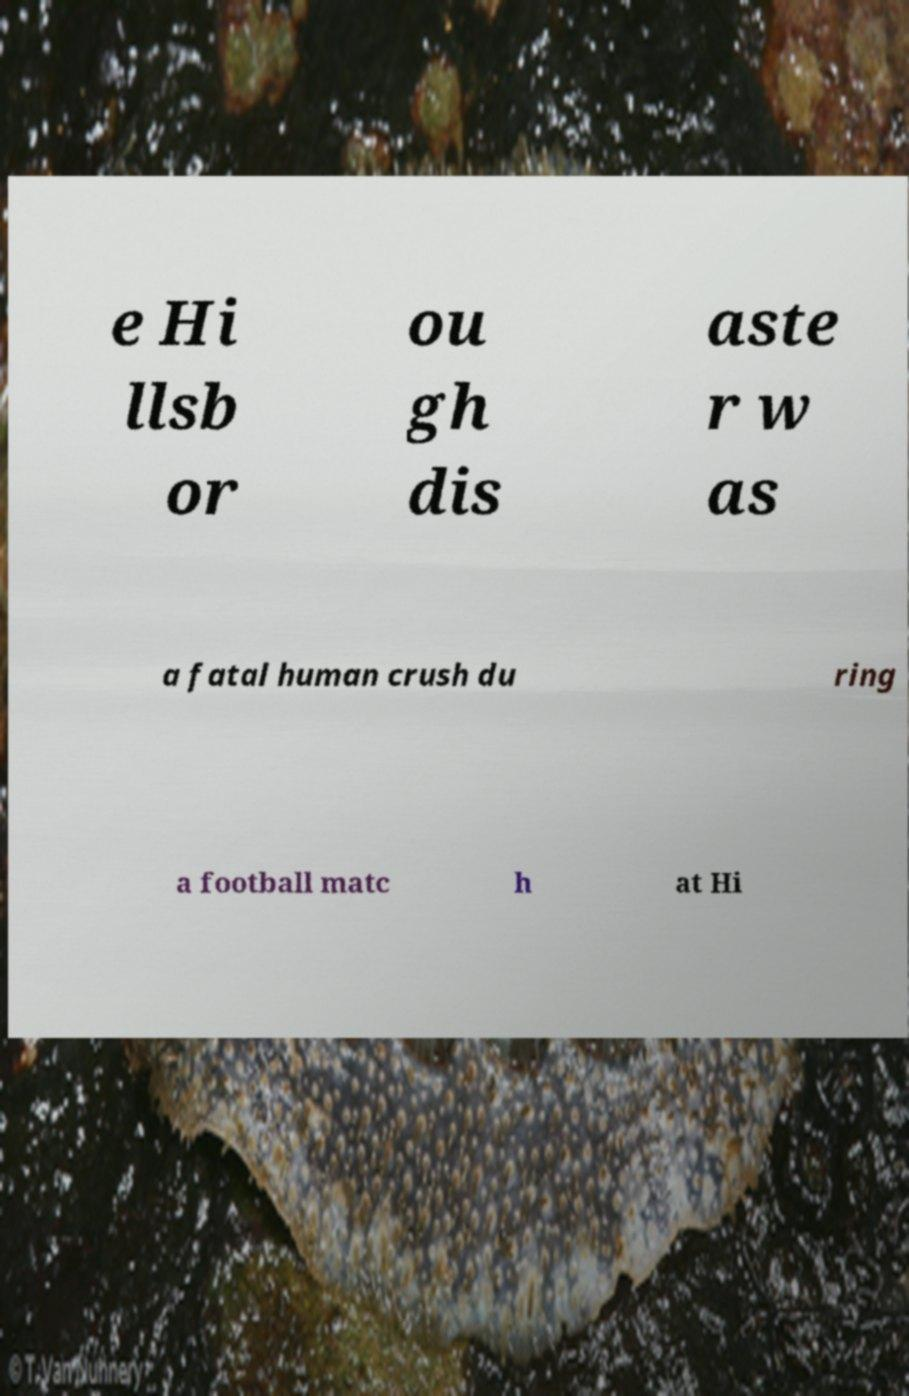Please read and relay the text visible in this image. What does it say? e Hi llsb or ou gh dis aste r w as a fatal human crush du ring a football matc h at Hi 